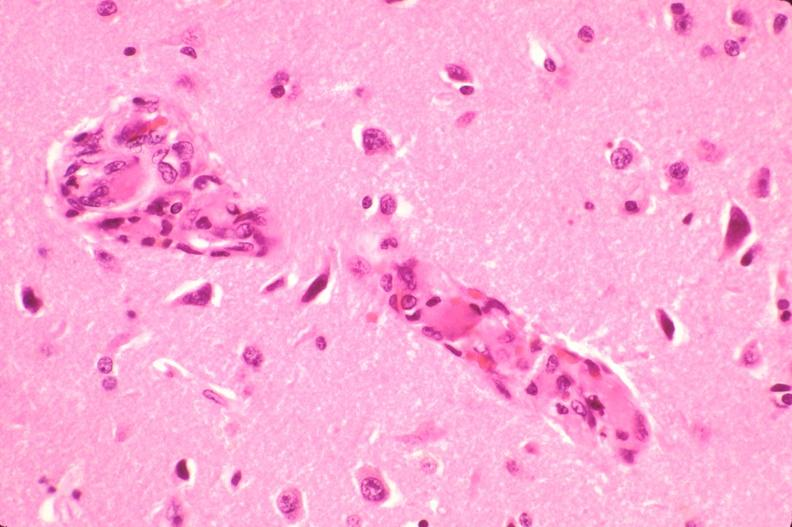where is this?
Answer the question using a single word or phrase. Nervous 